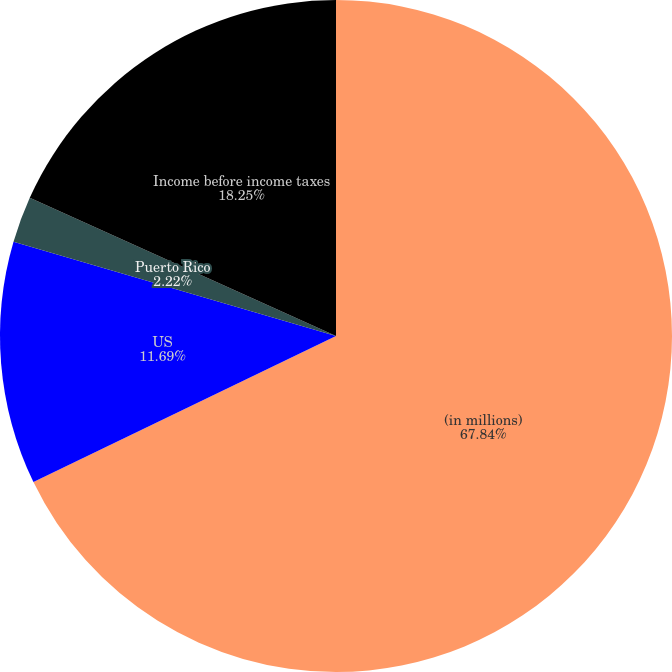Convert chart. <chart><loc_0><loc_0><loc_500><loc_500><pie_chart><fcel>(in millions)<fcel>US<fcel>Puerto Rico<fcel>Income before income taxes<nl><fcel>67.84%<fcel>11.69%<fcel>2.22%<fcel>18.25%<nl></chart> 